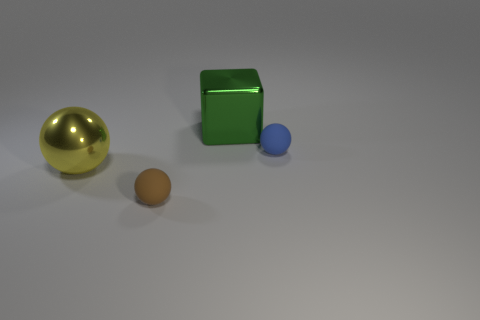What does the arrangement of these objects make you feel or think about? The arrangement of objects, with varying sizes and distances, gives a sense of intentional design that reflects on themes of balance and proportion. It evokes thoughts about the way individual components within a system can coexist harmoniously, despite differences. The isolated and unadorned setting might also inspire thoughts about isolation or the relationship between objects in space. 